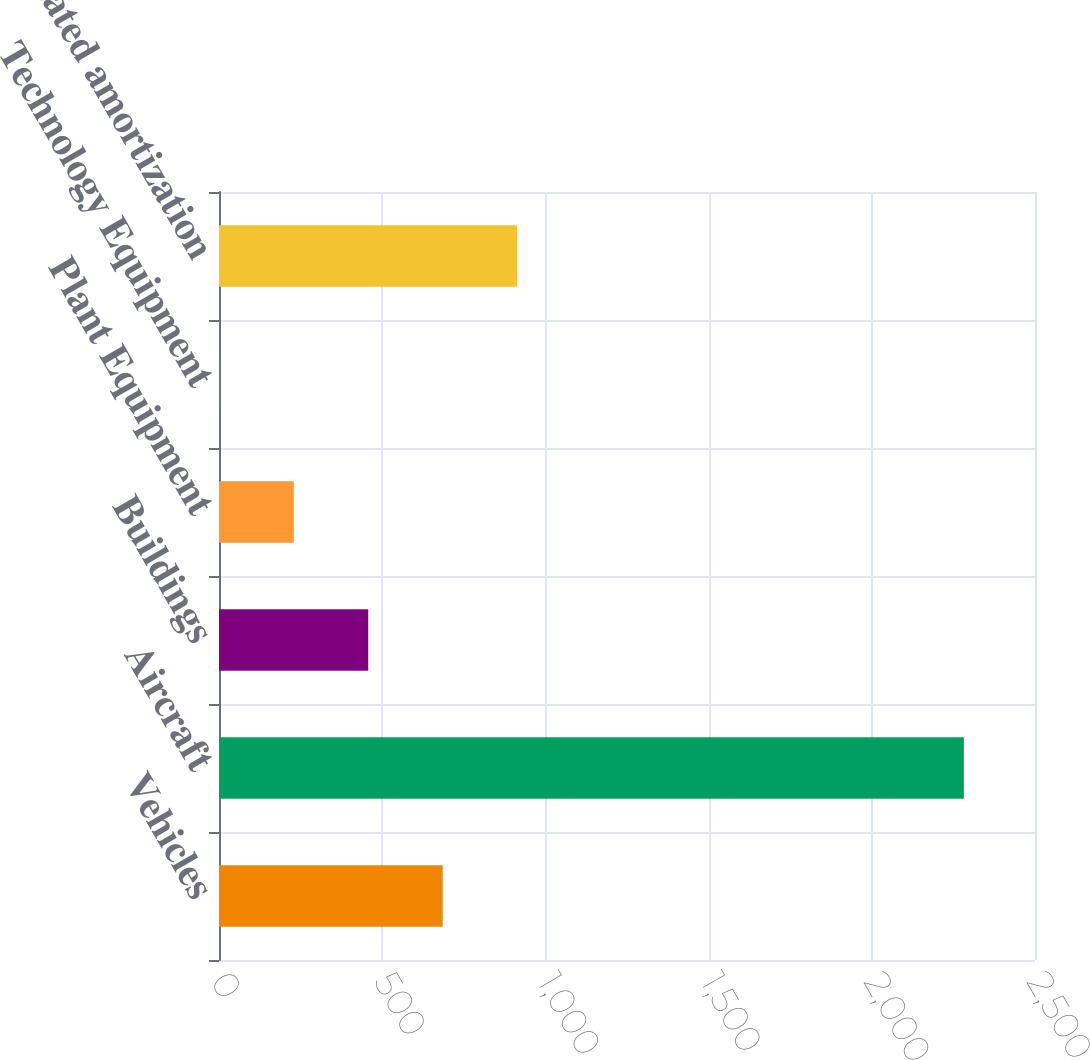<chart> <loc_0><loc_0><loc_500><loc_500><bar_chart><fcel>Vehicles<fcel>Aircraft<fcel>Buildings<fcel>Plant Equipment<fcel>Technology Equipment<fcel>Accumulated amortization<nl><fcel>685.3<fcel>2282<fcel>457.2<fcel>229.1<fcel>1<fcel>913.4<nl></chart> 